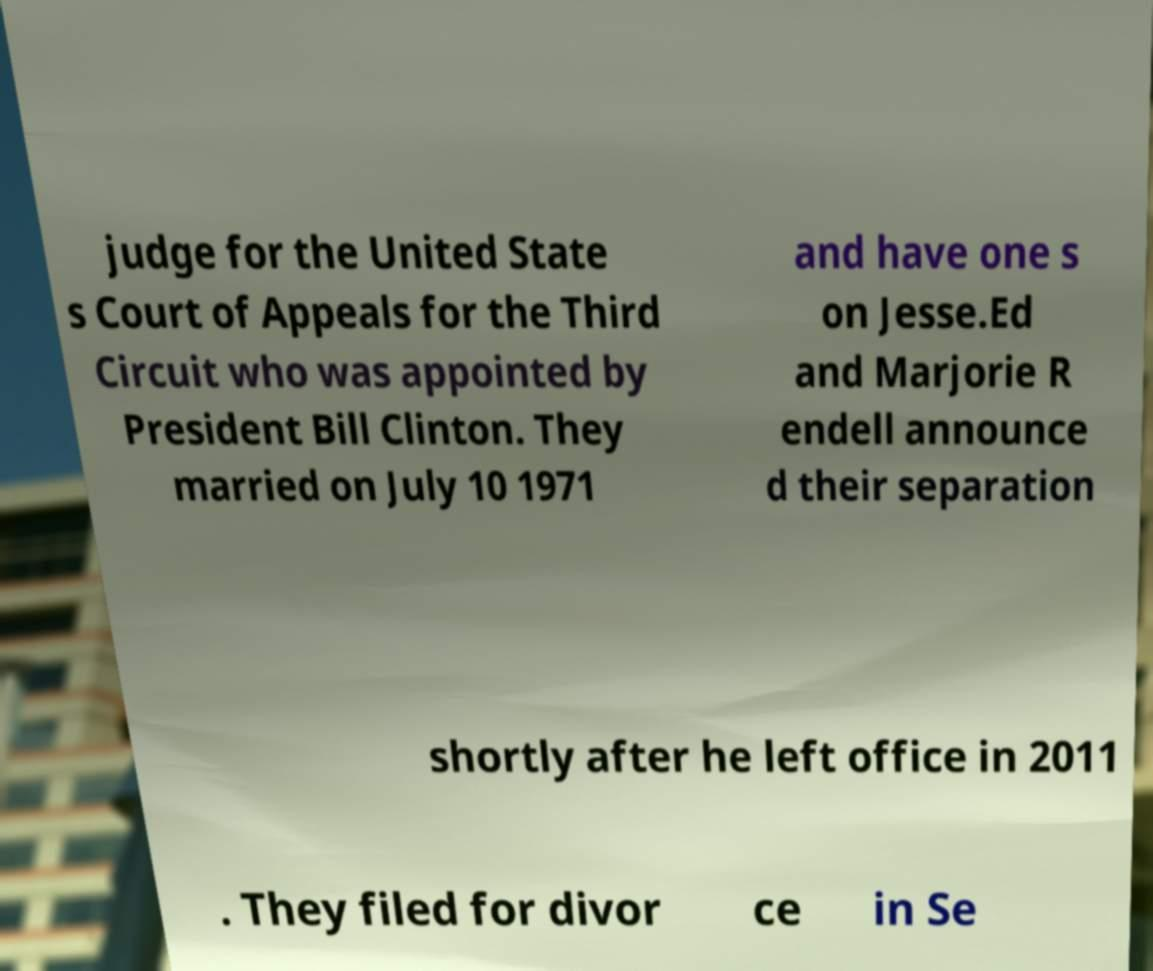Could you extract and type out the text from this image? judge for the United State s Court of Appeals for the Third Circuit who was appointed by President Bill Clinton. They married on July 10 1971 and have one s on Jesse.Ed and Marjorie R endell announce d their separation shortly after he left office in 2011 . They filed for divor ce in Se 